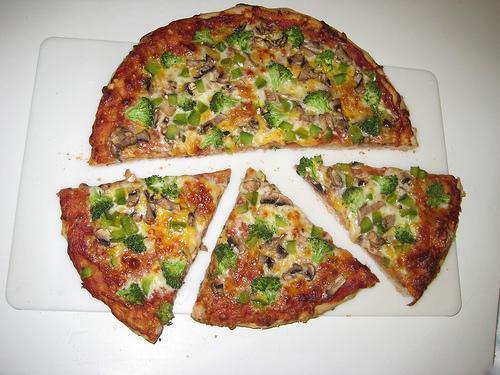How many slices have been cut out of the pizza?
Give a very brief answer. 3. How many slices are shown?
Give a very brief answer. 3. How many slices make up the other half of the pizza?
Give a very brief answer. 3. How many sections of the pizza are shown?
Give a very brief answer. 4. 